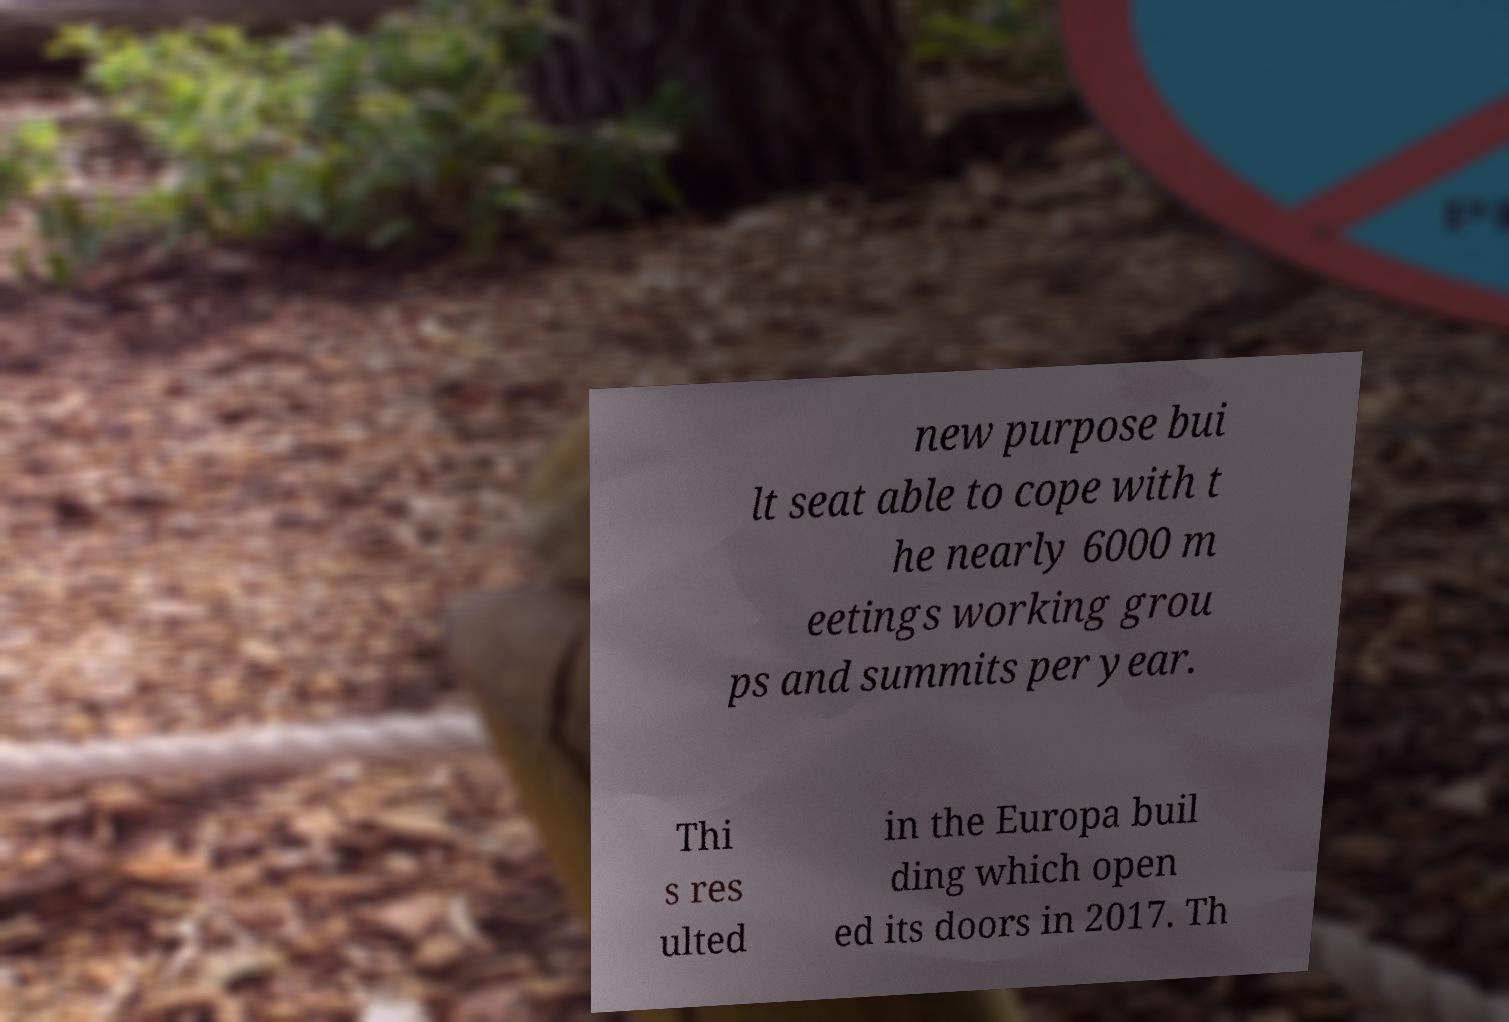I need the written content from this picture converted into text. Can you do that? new purpose bui lt seat able to cope with t he nearly 6000 m eetings working grou ps and summits per year. Thi s res ulted in the Europa buil ding which open ed its doors in 2017. Th 